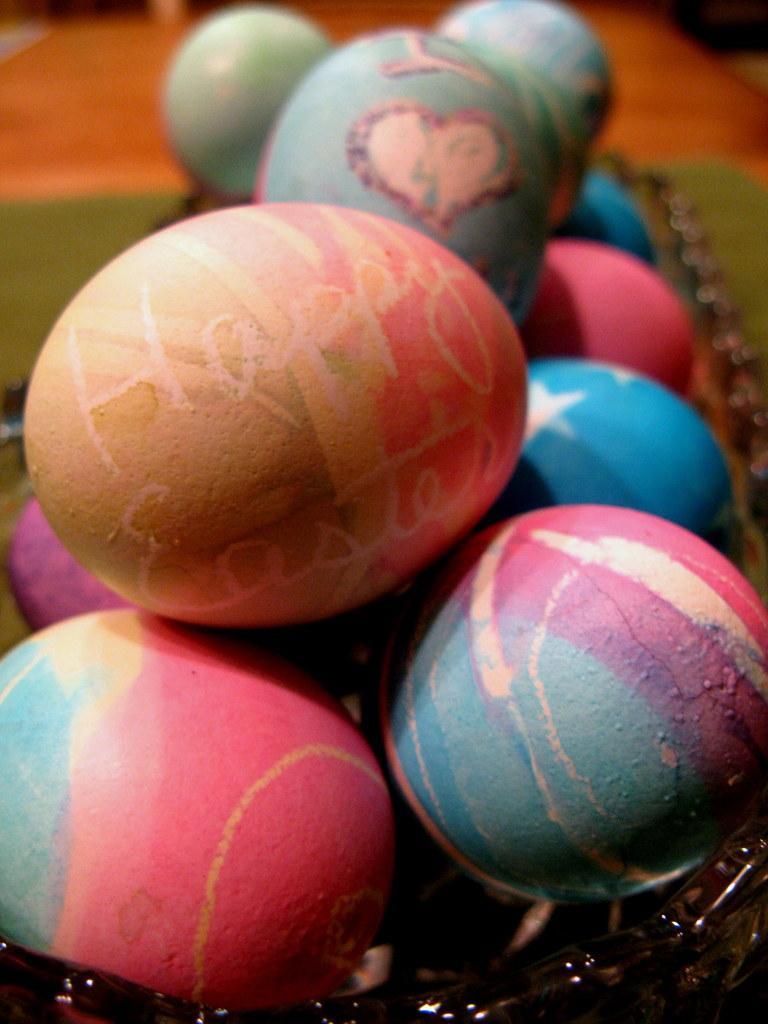In one or two sentences, can you explain what this image depicts? In this picture we can see a few colorful eggs. There is a text visible on one of the eggs. Background is blurry. 